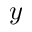<formula> <loc_0><loc_0><loc_500><loc_500>y</formula> 